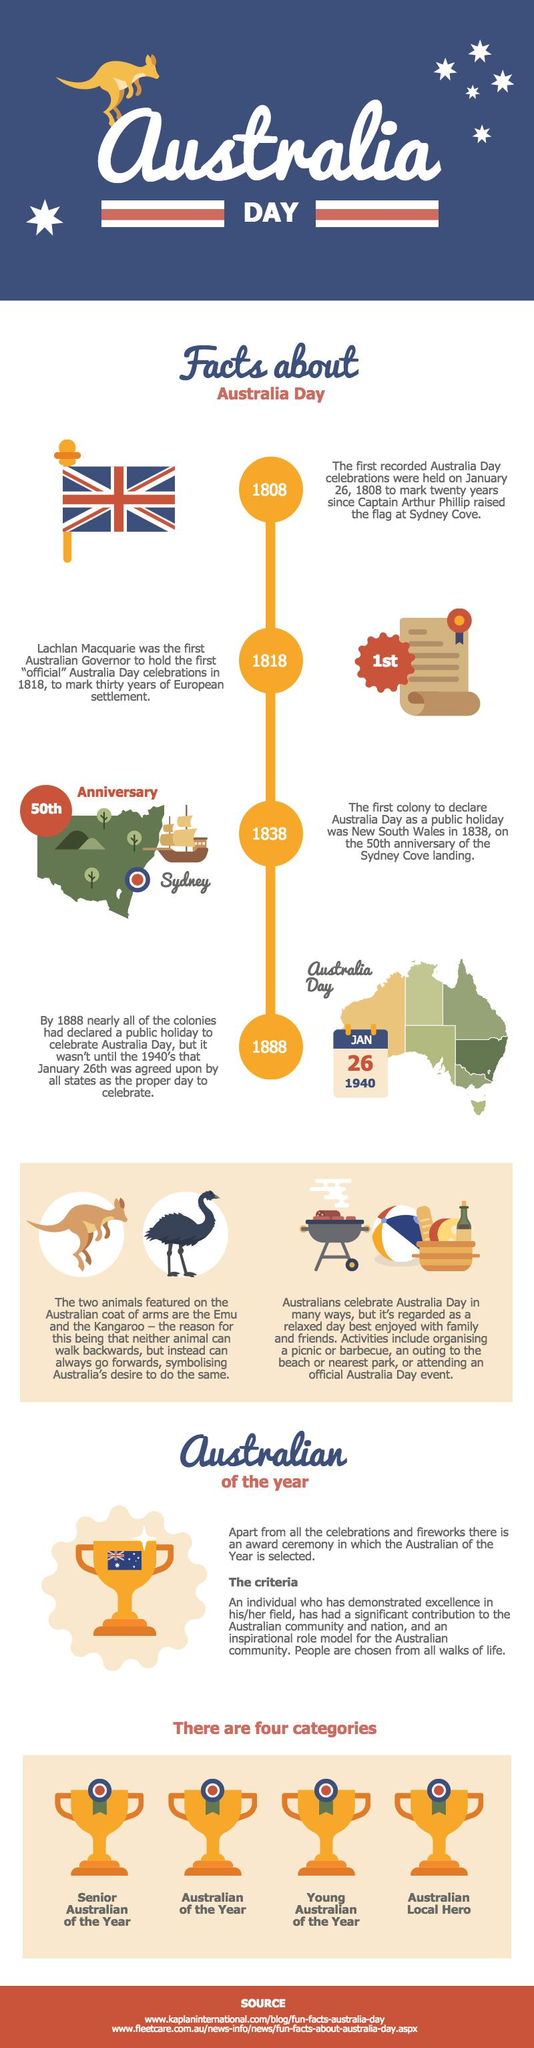List a handful of essential elements in this visual. The first recorded Australia Day celebrations were held in 1808. New South Wales was the first colony to declare Australia Day as a public holiday. 